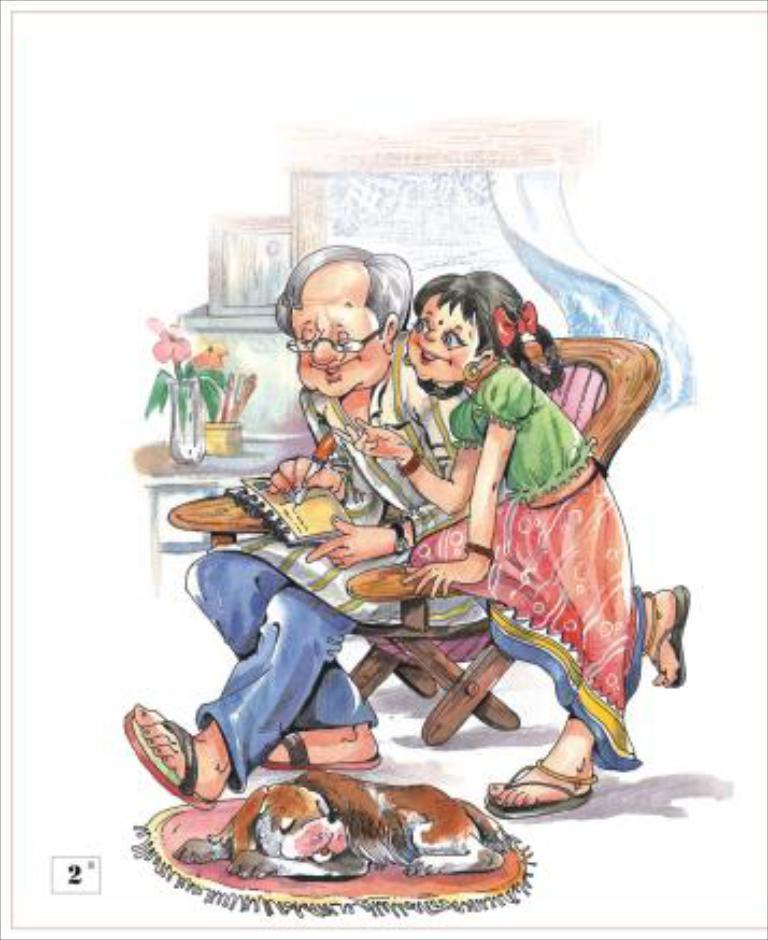What is the main subject of the image? There is a drawing in the image. Who or what is depicted in the drawing? There are people and a dog sitting in the image. What other elements are present in the drawing? There is a plant and flowers in the image. What type of request is being made by the army in the image? There is no army present in the image, so no such request can be observed. 